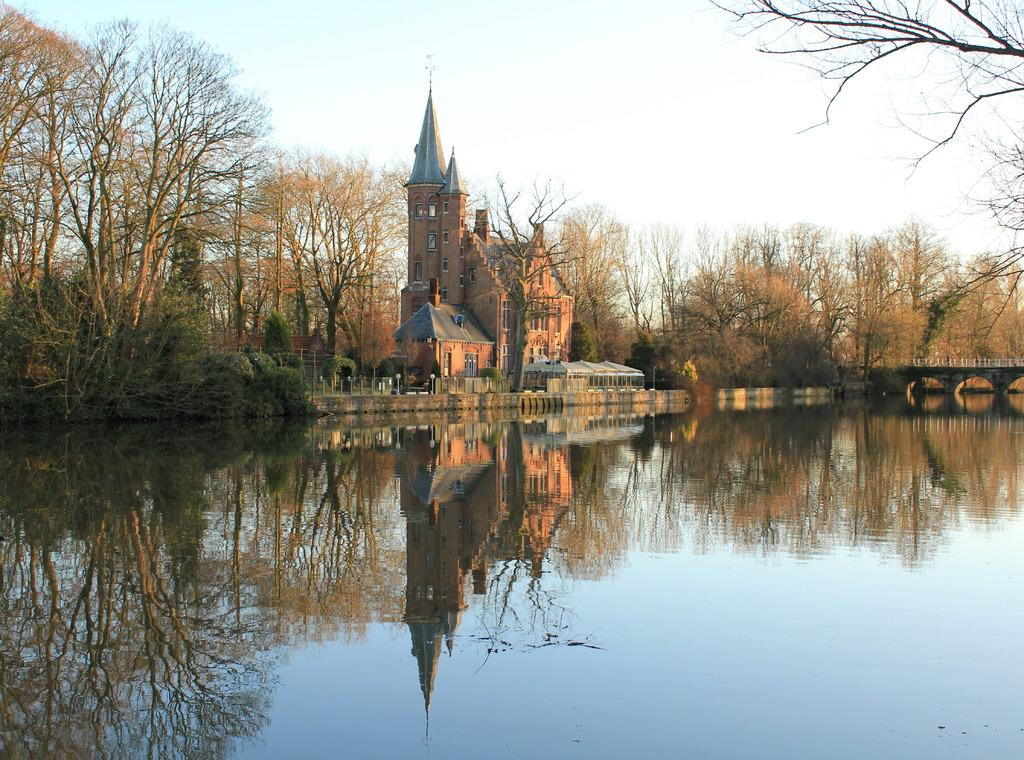What type of structures can be seen in the image? There are buildings with windows in the image. What other natural elements are present in the image? There are trees in the image. Is there a specific route or path visible in the image? Yes, there is a path in the image. What can be seen in the water in the image? There are reflections on the water. What part of the natural environment is visible in the image? The sky is visible in the image. What type of oatmeal is being served in the image? There is no oatmeal present in the image. How many pies are visible on the path in the image? There are no pies visible in the image; the path is clear. 